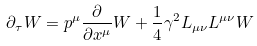<formula> <loc_0><loc_0><loc_500><loc_500>\partial _ { \tau } W = p ^ { \mu } \frac { \partial } { \partial x ^ { \mu } } W + \frac { 1 } { 4 } \gamma ^ { 2 } L _ { \mu \nu } L ^ { \mu \nu } W</formula> 